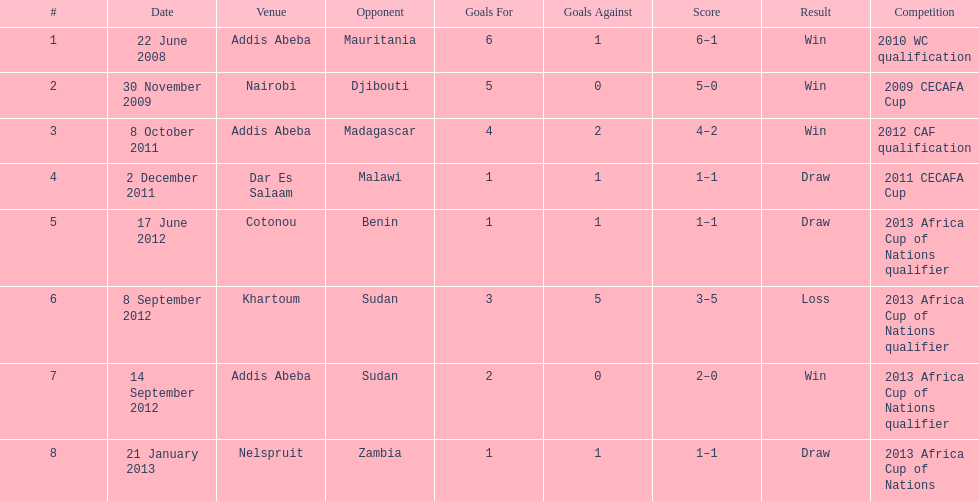Number of different teams listed on the chart 7. 